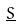<formula> <loc_0><loc_0><loc_500><loc_500>\underline { S }</formula> 